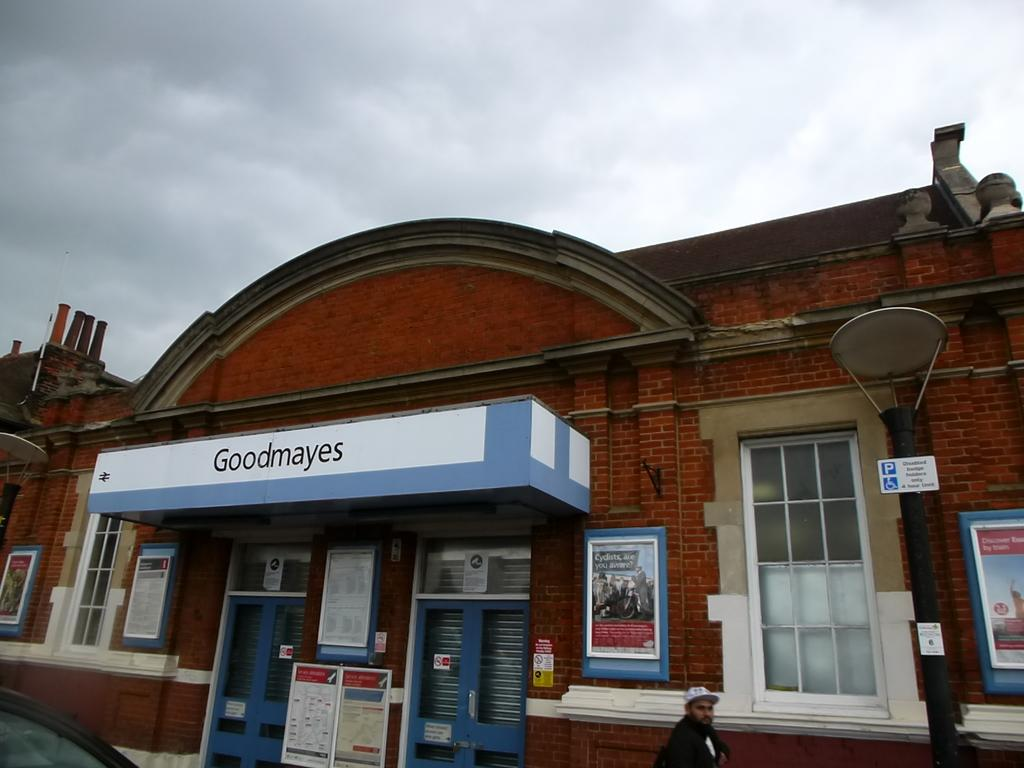What type of structure is visible in the image? There is a building in the image. What other objects can be seen in the image? There are poles, boards, and a person visible in the image. What is visible at the top of the image? Clouds are visible at the top of the image. Can you describe the vehicle in the image? It appears there is a car in the left bottom of the image. How many sisters are sitting on the boards in the image? There are no sisters present in the image; only a person is visible. What type of needle is being used by the person in the image? There is no needle present in the image; the person is not performing any activity that would require a needle. 